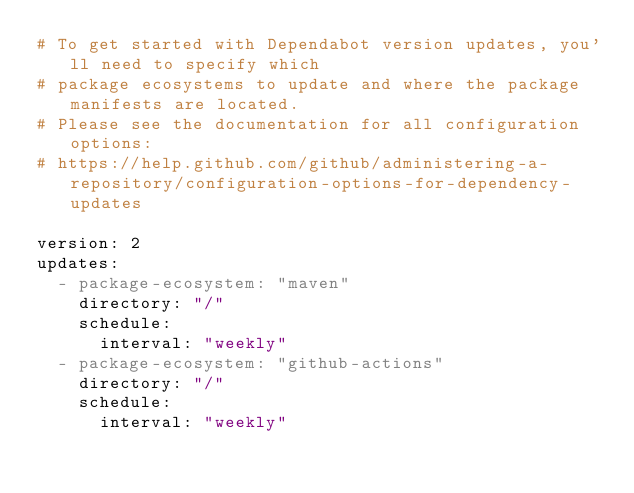Convert code to text. <code><loc_0><loc_0><loc_500><loc_500><_YAML_># To get started with Dependabot version updates, you'll need to specify which
# package ecosystems to update and where the package manifests are located.
# Please see the documentation for all configuration options:
# https://help.github.com/github/administering-a-repository/configuration-options-for-dependency-updates

version: 2
updates:
  - package-ecosystem: "maven"
    directory: "/"
    schedule:
      interval: "weekly"
  - package-ecosystem: "github-actions"
    directory: "/"
    schedule:
      interval: "weekly"
</code> 